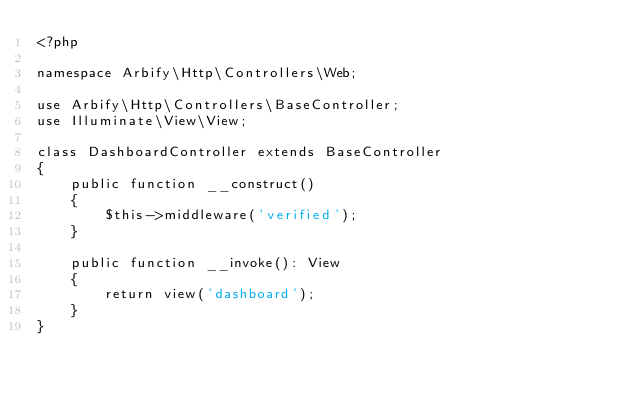Convert code to text. <code><loc_0><loc_0><loc_500><loc_500><_PHP_><?php

namespace Arbify\Http\Controllers\Web;

use Arbify\Http\Controllers\BaseController;
use Illuminate\View\View;

class DashboardController extends BaseController
{
    public function __construct()
    {
        $this->middleware('verified');
    }

    public function __invoke(): View
    {
        return view('dashboard');
    }
}
</code> 